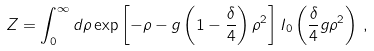Convert formula to latex. <formula><loc_0><loc_0><loc_500><loc_500>Z = \int _ { 0 } ^ { \infty } d \rho \exp \left [ - \rho - g \left ( 1 - \frac { \delta } { 4 } \right ) { \rho } ^ { 2 } \right ] I _ { 0 } \left ( \frac { \delta } { 4 } g { \rho } ^ { 2 } \right ) \, ,</formula> 